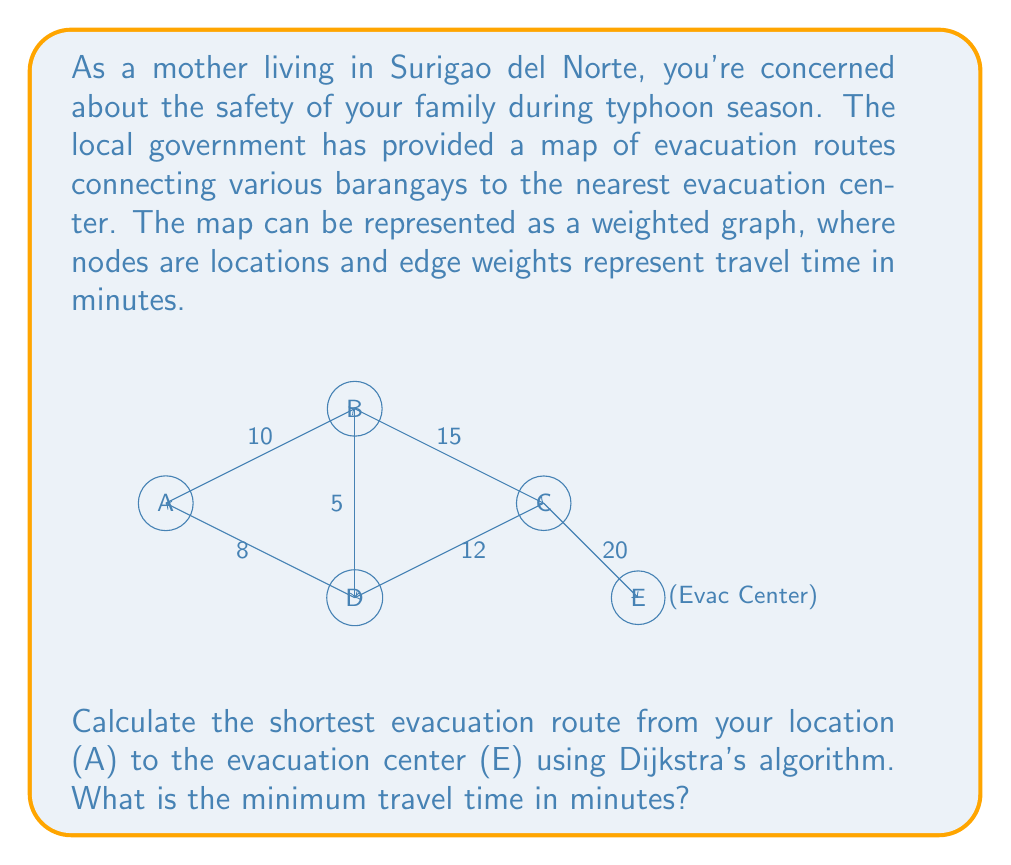Help me with this question. To solve this problem using Dijkstra's algorithm, we'll follow these steps:

1) Initialize:
   - Set distance to A as 0, and all other nodes as infinity.
   - Set all nodes as unvisited.
   - Set A as the current node.

2) For the current node, calculate the distance to all unvisited neighbors:
   - A to B: 0 + 10 = 10
   - A to D: 0 + 8 = 8

3) Update distances if shorter path found and mark A as visited.

4) Select the unvisited node with the smallest distance (D) as the new current node.

5) From D:
   - D to B: 8 + 5 = 13 (longer than current B, so no update)
   - D to C: 8 + 12 = 20

6) Mark D as visited. Select B (distance 10) as the new current node.

7) From B:
   - B to C: 10 + 15 = 25 (longer than current C, so no update)

8) Mark B as visited. Select C (distance 20) as the new current node.

9) From C:
   - C to E: 20 + 20 = 40

10) Mark C as visited. E is the only unvisited node left.

The shortest path is A -> D -> C -> E with a total distance of 40 minutes.
Answer: 40 minutes 